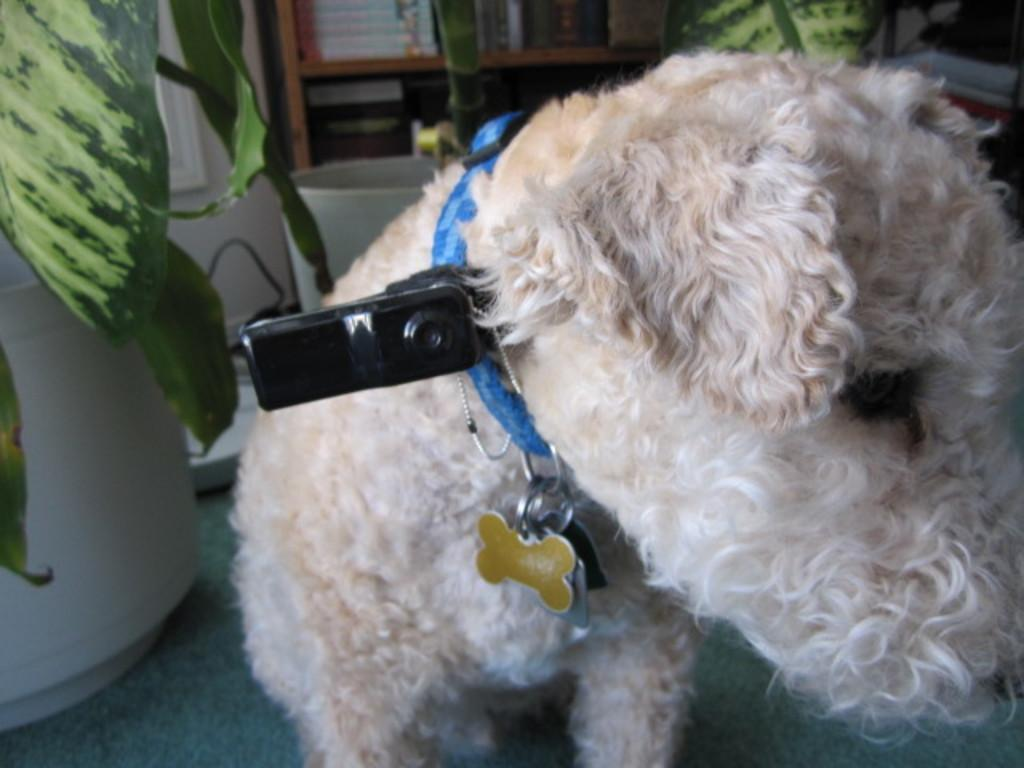What type of animal is present in the image? There is a dog in the image. What is the dog wearing? The dog is wearing a dog belt. What other objects can be seen in the image? There are flower pots in the image. Who is the creator of the shelf in the image? There is no shelf present in the image. 